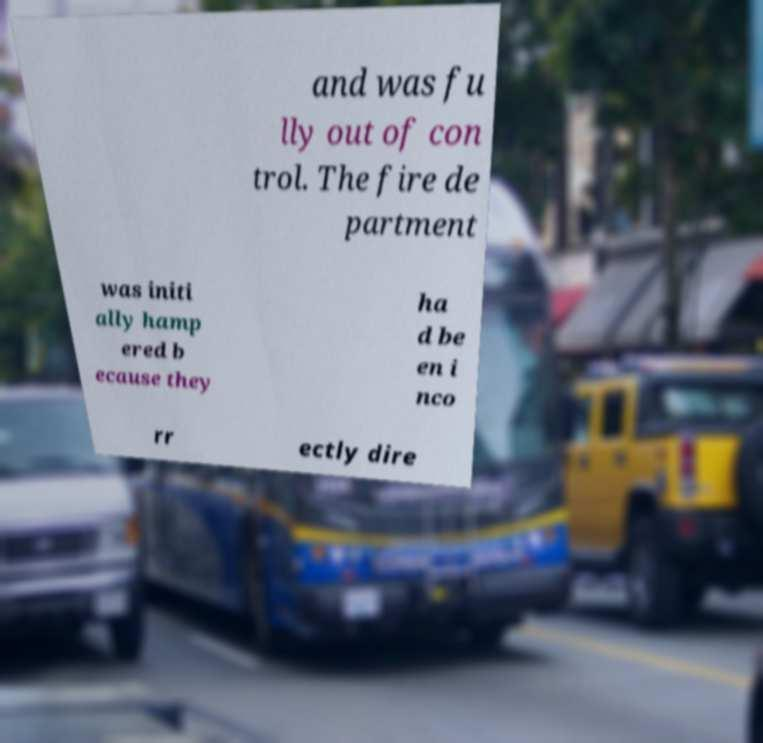I need the written content from this picture converted into text. Can you do that? and was fu lly out of con trol. The fire de partment was initi ally hamp ered b ecause they ha d be en i nco rr ectly dire 